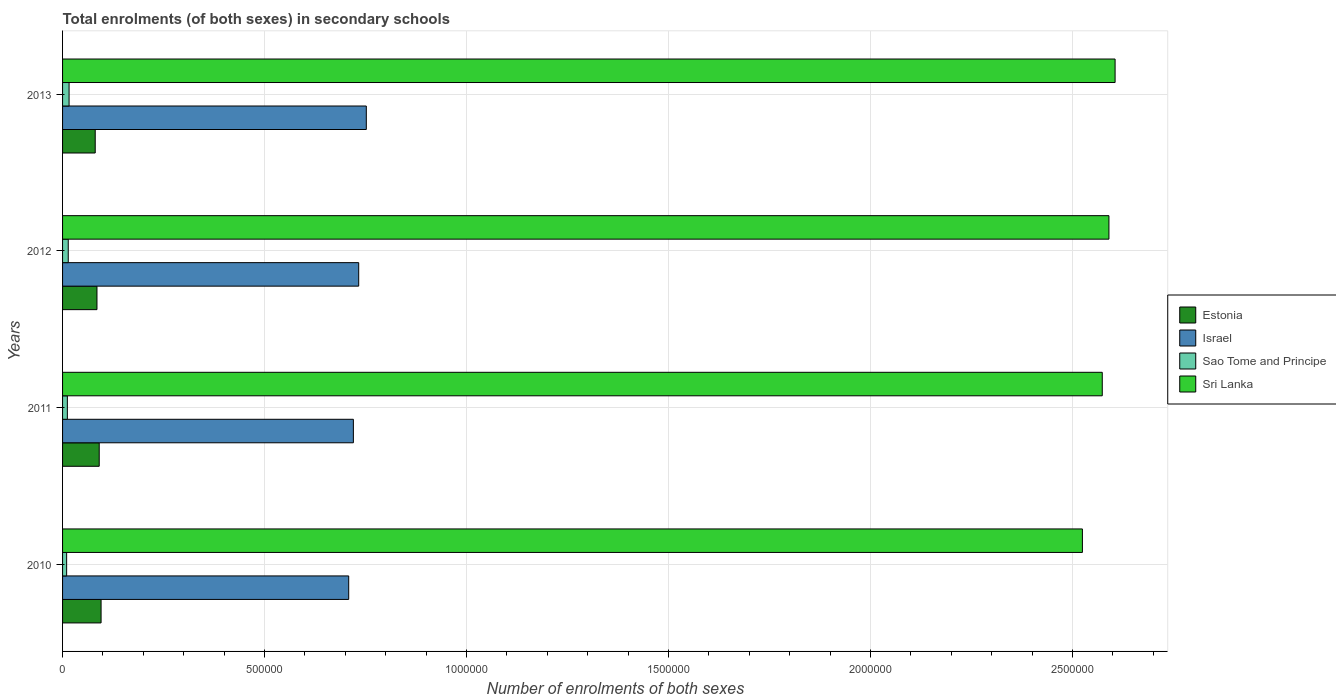Are the number of bars per tick equal to the number of legend labels?
Your answer should be compact. Yes. Are the number of bars on each tick of the Y-axis equal?
Offer a terse response. Yes. How many bars are there on the 1st tick from the bottom?
Provide a short and direct response. 4. In how many cases, is the number of bars for a given year not equal to the number of legend labels?
Your answer should be compact. 0. What is the number of enrolments in secondary schools in Sri Lanka in 2011?
Give a very brief answer. 2.57e+06. Across all years, what is the maximum number of enrolments in secondary schools in Sri Lanka?
Provide a short and direct response. 2.61e+06. Across all years, what is the minimum number of enrolments in secondary schools in Sao Tome and Principe?
Your response must be concise. 1.01e+04. In which year was the number of enrolments in secondary schools in Israel minimum?
Ensure brevity in your answer.  2010. What is the total number of enrolments in secondary schools in Sri Lanka in the graph?
Your answer should be very brief. 1.03e+07. What is the difference between the number of enrolments in secondary schools in Israel in 2011 and that in 2013?
Provide a short and direct response. -3.20e+04. What is the difference between the number of enrolments in secondary schools in Sao Tome and Principe in 2013 and the number of enrolments in secondary schools in Israel in 2012?
Provide a succinct answer. -7.17e+05. What is the average number of enrolments in secondary schools in Sri Lanka per year?
Your answer should be very brief. 2.57e+06. In the year 2011, what is the difference between the number of enrolments in secondary schools in Sao Tome and Principe and number of enrolments in secondary schools in Israel?
Ensure brevity in your answer.  -7.08e+05. In how many years, is the number of enrolments in secondary schools in Sri Lanka greater than 400000 ?
Your answer should be very brief. 4. What is the ratio of the number of enrolments in secondary schools in Sri Lanka in 2011 to that in 2012?
Provide a short and direct response. 0.99. Is the difference between the number of enrolments in secondary schools in Sao Tome and Principe in 2010 and 2012 greater than the difference between the number of enrolments in secondary schools in Israel in 2010 and 2012?
Give a very brief answer. Yes. What is the difference between the highest and the second highest number of enrolments in secondary schools in Sri Lanka?
Offer a very short reply. 1.52e+04. What is the difference between the highest and the lowest number of enrolments in secondary schools in Estonia?
Ensure brevity in your answer.  1.45e+04. In how many years, is the number of enrolments in secondary schools in Sao Tome and Principe greater than the average number of enrolments in secondary schools in Sao Tome and Principe taken over all years?
Your answer should be compact. 2. Is it the case that in every year, the sum of the number of enrolments in secondary schools in Estonia and number of enrolments in secondary schools in Israel is greater than the sum of number of enrolments in secondary schools in Sao Tome and Principe and number of enrolments in secondary schools in Sri Lanka?
Your answer should be compact. No. What does the 4th bar from the top in 2012 represents?
Your answer should be very brief. Estonia. What does the 1st bar from the bottom in 2013 represents?
Keep it short and to the point. Estonia. Is it the case that in every year, the sum of the number of enrolments in secondary schools in Israel and number of enrolments in secondary schools in Estonia is greater than the number of enrolments in secondary schools in Sao Tome and Principe?
Offer a very short reply. Yes. How many bars are there?
Provide a succinct answer. 16. Are all the bars in the graph horizontal?
Your answer should be compact. Yes. How many years are there in the graph?
Offer a terse response. 4. What is the difference between two consecutive major ticks on the X-axis?
Keep it short and to the point. 5.00e+05. How are the legend labels stacked?
Offer a terse response. Vertical. What is the title of the graph?
Provide a short and direct response. Total enrolments (of both sexes) in secondary schools. Does "South Africa" appear as one of the legend labels in the graph?
Ensure brevity in your answer.  No. What is the label or title of the X-axis?
Keep it short and to the point. Number of enrolments of both sexes. What is the Number of enrolments of both sexes in Estonia in 2010?
Keep it short and to the point. 9.53e+04. What is the Number of enrolments of both sexes of Israel in 2010?
Keep it short and to the point. 7.08e+05. What is the Number of enrolments of both sexes in Sao Tome and Principe in 2010?
Your answer should be very brief. 1.01e+04. What is the Number of enrolments of both sexes in Sri Lanka in 2010?
Make the answer very short. 2.52e+06. What is the Number of enrolments of both sexes of Estonia in 2011?
Offer a very short reply. 9.07e+04. What is the Number of enrolments of both sexes of Israel in 2011?
Offer a very short reply. 7.20e+05. What is the Number of enrolments of both sexes in Sao Tome and Principe in 2011?
Provide a succinct answer. 1.19e+04. What is the Number of enrolments of both sexes of Sri Lanka in 2011?
Provide a succinct answer. 2.57e+06. What is the Number of enrolments of both sexes of Estonia in 2012?
Your answer should be very brief. 8.52e+04. What is the Number of enrolments of both sexes in Israel in 2012?
Offer a terse response. 7.33e+05. What is the Number of enrolments of both sexes of Sao Tome and Principe in 2012?
Give a very brief answer. 1.41e+04. What is the Number of enrolments of both sexes in Sri Lanka in 2012?
Offer a very short reply. 2.59e+06. What is the Number of enrolments of both sexes in Estonia in 2013?
Your answer should be very brief. 8.08e+04. What is the Number of enrolments of both sexes in Israel in 2013?
Your response must be concise. 7.52e+05. What is the Number of enrolments of both sexes in Sao Tome and Principe in 2013?
Your answer should be very brief. 1.61e+04. What is the Number of enrolments of both sexes in Sri Lanka in 2013?
Your answer should be very brief. 2.61e+06. Across all years, what is the maximum Number of enrolments of both sexes in Estonia?
Offer a terse response. 9.53e+04. Across all years, what is the maximum Number of enrolments of both sexes of Israel?
Your answer should be very brief. 7.52e+05. Across all years, what is the maximum Number of enrolments of both sexes in Sao Tome and Principe?
Offer a terse response. 1.61e+04. Across all years, what is the maximum Number of enrolments of both sexes of Sri Lanka?
Make the answer very short. 2.61e+06. Across all years, what is the minimum Number of enrolments of both sexes of Estonia?
Offer a terse response. 8.08e+04. Across all years, what is the minimum Number of enrolments of both sexes in Israel?
Offer a terse response. 7.08e+05. Across all years, what is the minimum Number of enrolments of both sexes of Sao Tome and Principe?
Offer a terse response. 1.01e+04. Across all years, what is the minimum Number of enrolments of both sexes of Sri Lanka?
Your response must be concise. 2.52e+06. What is the total Number of enrolments of both sexes in Estonia in the graph?
Provide a short and direct response. 3.52e+05. What is the total Number of enrolments of both sexes of Israel in the graph?
Ensure brevity in your answer.  2.91e+06. What is the total Number of enrolments of both sexes of Sao Tome and Principe in the graph?
Provide a short and direct response. 5.22e+04. What is the total Number of enrolments of both sexes in Sri Lanka in the graph?
Ensure brevity in your answer.  1.03e+07. What is the difference between the Number of enrolments of both sexes of Estonia in 2010 and that in 2011?
Keep it short and to the point. 4614. What is the difference between the Number of enrolments of both sexes of Israel in 2010 and that in 2011?
Make the answer very short. -1.16e+04. What is the difference between the Number of enrolments of both sexes in Sao Tome and Principe in 2010 and that in 2011?
Offer a very short reply. -1787. What is the difference between the Number of enrolments of both sexes of Sri Lanka in 2010 and that in 2011?
Keep it short and to the point. -4.92e+04. What is the difference between the Number of enrolments of both sexes of Estonia in 2010 and that in 2012?
Offer a very short reply. 1.01e+04. What is the difference between the Number of enrolments of both sexes of Israel in 2010 and that in 2012?
Keep it short and to the point. -2.48e+04. What is the difference between the Number of enrolments of both sexes of Sao Tome and Principe in 2010 and that in 2012?
Keep it short and to the point. -3964. What is the difference between the Number of enrolments of both sexes in Sri Lanka in 2010 and that in 2012?
Your response must be concise. -6.57e+04. What is the difference between the Number of enrolments of both sexes of Estonia in 2010 and that in 2013?
Your answer should be very brief. 1.45e+04. What is the difference between the Number of enrolments of both sexes of Israel in 2010 and that in 2013?
Give a very brief answer. -4.36e+04. What is the difference between the Number of enrolments of both sexes of Sao Tome and Principe in 2010 and that in 2013?
Offer a very short reply. -6021. What is the difference between the Number of enrolments of both sexes of Sri Lanka in 2010 and that in 2013?
Keep it short and to the point. -8.09e+04. What is the difference between the Number of enrolments of both sexes of Estonia in 2011 and that in 2012?
Provide a succinct answer. 5534. What is the difference between the Number of enrolments of both sexes of Israel in 2011 and that in 2012?
Make the answer very short. -1.32e+04. What is the difference between the Number of enrolments of both sexes in Sao Tome and Principe in 2011 and that in 2012?
Keep it short and to the point. -2177. What is the difference between the Number of enrolments of both sexes in Sri Lanka in 2011 and that in 2012?
Provide a succinct answer. -1.65e+04. What is the difference between the Number of enrolments of both sexes in Estonia in 2011 and that in 2013?
Keep it short and to the point. 9877. What is the difference between the Number of enrolments of both sexes in Israel in 2011 and that in 2013?
Make the answer very short. -3.20e+04. What is the difference between the Number of enrolments of both sexes of Sao Tome and Principe in 2011 and that in 2013?
Your answer should be very brief. -4234. What is the difference between the Number of enrolments of both sexes of Sri Lanka in 2011 and that in 2013?
Keep it short and to the point. -3.18e+04. What is the difference between the Number of enrolments of both sexes of Estonia in 2012 and that in 2013?
Your answer should be very brief. 4343. What is the difference between the Number of enrolments of both sexes in Israel in 2012 and that in 2013?
Your answer should be very brief. -1.88e+04. What is the difference between the Number of enrolments of both sexes of Sao Tome and Principe in 2012 and that in 2013?
Ensure brevity in your answer.  -2057. What is the difference between the Number of enrolments of both sexes in Sri Lanka in 2012 and that in 2013?
Your response must be concise. -1.52e+04. What is the difference between the Number of enrolments of both sexes of Estonia in 2010 and the Number of enrolments of both sexes of Israel in 2011?
Provide a succinct answer. -6.25e+05. What is the difference between the Number of enrolments of both sexes in Estonia in 2010 and the Number of enrolments of both sexes in Sao Tome and Principe in 2011?
Give a very brief answer. 8.34e+04. What is the difference between the Number of enrolments of both sexes in Estonia in 2010 and the Number of enrolments of both sexes in Sri Lanka in 2011?
Keep it short and to the point. -2.48e+06. What is the difference between the Number of enrolments of both sexes of Israel in 2010 and the Number of enrolments of both sexes of Sao Tome and Principe in 2011?
Make the answer very short. 6.96e+05. What is the difference between the Number of enrolments of both sexes of Israel in 2010 and the Number of enrolments of both sexes of Sri Lanka in 2011?
Make the answer very short. -1.87e+06. What is the difference between the Number of enrolments of both sexes in Sao Tome and Principe in 2010 and the Number of enrolments of both sexes in Sri Lanka in 2011?
Give a very brief answer. -2.56e+06. What is the difference between the Number of enrolments of both sexes in Estonia in 2010 and the Number of enrolments of both sexes in Israel in 2012?
Ensure brevity in your answer.  -6.38e+05. What is the difference between the Number of enrolments of both sexes of Estonia in 2010 and the Number of enrolments of both sexes of Sao Tome and Principe in 2012?
Ensure brevity in your answer.  8.13e+04. What is the difference between the Number of enrolments of both sexes of Estonia in 2010 and the Number of enrolments of both sexes of Sri Lanka in 2012?
Ensure brevity in your answer.  -2.50e+06. What is the difference between the Number of enrolments of both sexes in Israel in 2010 and the Number of enrolments of both sexes in Sao Tome and Principe in 2012?
Your answer should be very brief. 6.94e+05. What is the difference between the Number of enrolments of both sexes in Israel in 2010 and the Number of enrolments of both sexes in Sri Lanka in 2012?
Keep it short and to the point. -1.88e+06. What is the difference between the Number of enrolments of both sexes of Sao Tome and Principe in 2010 and the Number of enrolments of both sexes of Sri Lanka in 2012?
Offer a terse response. -2.58e+06. What is the difference between the Number of enrolments of both sexes of Estonia in 2010 and the Number of enrolments of both sexes of Israel in 2013?
Make the answer very short. -6.57e+05. What is the difference between the Number of enrolments of both sexes in Estonia in 2010 and the Number of enrolments of both sexes in Sao Tome and Principe in 2013?
Provide a succinct answer. 7.92e+04. What is the difference between the Number of enrolments of both sexes in Estonia in 2010 and the Number of enrolments of both sexes in Sri Lanka in 2013?
Keep it short and to the point. -2.51e+06. What is the difference between the Number of enrolments of both sexes in Israel in 2010 and the Number of enrolments of both sexes in Sao Tome and Principe in 2013?
Provide a short and direct response. 6.92e+05. What is the difference between the Number of enrolments of both sexes in Israel in 2010 and the Number of enrolments of both sexes in Sri Lanka in 2013?
Keep it short and to the point. -1.90e+06. What is the difference between the Number of enrolments of both sexes in Sao Tome and Principe in 2010 and the Number of enrolments of both sexes in Sri Lanka in 2013?
Provide a succinct answer. -2.60e+06. What is the difference between the Number of enrolments of both sexes of Estonia in 2011 and the Number of enrolments of both sexes of Israel in 2012?
Provide a succinct answer. -6.42e+05. What is the difference between the Number of enrolments of both sexes of Estonia in 2011 and the Number of enrolments of both sexes of Sao Tome and Principe in 2012?
Your answer should be compact. 7.67e+04. What is the difference between the Number of enrolments of both sexes of Estonia in 2011 and the Number of enrolments of both sexes of Sri Lanka in 2012?
Offer a terse response. -2.50e+06. What is the difference between the Number of enrolments of both sexes in Israel in 2011 and the Number of enrolments of both sexes in Sao Tome and Principe in 2012?
Your answer should be very brief. 7.06e+05. What is the difference between the Number of enrolments of both sexes in Israel in 2011 and the Number of enrolments of both sexes in Sri Lanka in 2012?
Provide a succinct answer. -1.87e+06. What is the difference between the Number of enrolments of both sexes of Sao Tome and Principe in 2011 and the Number of enrolments of both sexes of Sri Lanka in 2012?
Your answer should be very brief. -2.58e+06. What is the difference between the Number of enrolments of both sexes of Estonia in 2011 and the Number of enrolments of both sexes of Israel in 2013?
Your answer should be very brief. -6.61e+05. What is the difference between the Number of enrolments of both sexes of Estonia in 2011 and the Number of enrolments of both sexes of Sao Tome and Principe in 2013?
Provide a succinct answer. 7.46e+04. What is the difference between the Number of enrolments of both sexes in Estonia in 2011 and the Number of enrolments of both sexes in Sri Lanka in 2013?
Provide a short and direct response. -2.51e+06. What is the difference between the Number of enrolments of both sexes in Israel in 2011 and the Number of enrolments of both sexes in Sao Tome and Principe in 2013?
Offer a terse response. 7.04e+05. What is the difference between the Number of enrolments of both sexes of Israel in 2011 and the Number of enrolments of both sexes of Sri Lanka in 2013?
Your answer should be very brief. -1.89e+06. What is the difference between the Number of enrolments of both sexes in Sao Tome and Principe in 2011 and the Number of enrolments of both sexes in Sri Lanka in 2013?
Give a very brief answer. -2.59e+06. What is the difference between the Number of enrolments of both sexes of Estonia in 2012 and the Number of enrolments of both sexes of Israel in 2013?
Offer a terse response. -6.67e+05. What is the difference between the Number of enrolments of both sexes of Estonia in 2012 and the Number of enrolments of both sexes of Sao Tome and Principe in 2013?
Ensure brevity in your answer.  6.91e+04. What is the difference between the Number of enrolments of both sexes in Estonia in 2012 and the Number of enrolments of both sexes in Sri Lanka in 2013?
Give a very brief answer. -2.52e+06. What is the difference between the Number of enrolments of both sexes of Israel in 2012 and the Number of enrolments of both sexes of Sao Tome and Principe in 2013?
Your response must be concise. 7.17e+05. What is the difference between the Number of enrolments of both sexes of Israel in 2012 and the Number of enrolments of both sexes of Sri Lanka in 2013?
Provide a short and direct response. -1.87e+06. What is the difference between the Number of enrolments of both sexes in Sao Tome and Principe in 2012 and the Number of enrolments of both sexes in Sri Lanka in 2013?
Keep it short and to the point. -2.59e+06. What is the average Number of enrolments of both sexes in Estonia per year?
Make the answer very short. 8.80e+04. What is the average Number of enrolments of both sexes in Israel per year?
Provide a short and direct response. 7.28e+05. What is the average Number of enrolments of both sexes in Sao Tome and Principe per year?
Provide a short and direct response. 1.30e+04. What is the average Number of enrolments of both sexes in Sri Lanka per year?
Keep it short and to the point. 2.57e+06. In the year 2010, what is the difference between the Number of enrolments of both sexes of Estonia and Number of enrolments of both sexes of Israel?
Ensure brevity in your answer.  -6.13e+05. In the year 2010, what is the difference between the Number of enrolments of both sexes of Estonia and Number of enrolments of both sexes of Sao Tome and Principe?
Give a very brief answer. 8.52e+04. In the year 2010, what is the difference between the Number of enrolments of both sexes in Estonia and Number of enrolments of both sexes in Sri Lanka?
Give a very brief answer. -2.43e+06. In the year 2010, what is the difference between the Number of enrolments of both sexes of Israel and Number of enrolments of both sexes of Sao Tome and Principe?
Make the answer very short. 6.98e+05. In the year 2010, what is the difference between the Number of enrolments of both sexes of Israel and Number of enrolments of both sexes of Sri Lanka?
Ensure brevity in your answer.  -1.82e+06. In the year 2010, what is the difference between the Number of enrolments of both sexes in Sao Tome and Principe and Number of enrolments of both sexes in Sri Lanka?
Offer a terse response. -2.51e+06. In the year 2011, what is the difference between the Number of enrolments of both sexes of Estonia and Number of enrolments of both sexes of Israel?
Your response must be concise. -6.29e+05. In the year 2011, what is the difference between the Number of enrolments of both sexes of Estonia and Number of enrolments of both sexes of Sao Tome and Principe?
Keep it short and to the point. 7.88e+04. In the year 2011, what is the difference between the Number of enrolments of both sexes in Estonia and Number of enrolments of both sexes in Sri Lanka?
Ensure brevity in your answer.  -2.48e+06. In the year 2011, what is the difference between the Number of enrolments of both sexes of Israel and Number of enrolments of both sexes of Sao Tome and Principe?
Provide a succinct answer. 7.08e+05. In the year 2011, what is the difference between the Number of enrolments of both sexes in Israel and Number of enrolments of both sexes in Sri Lanka?
Offer a very short reply. -1.85e+06. In the year 2011, what is the difference between the Number of enrolments of both sexes of Sao Tome and Principe and Number of enrolments of both sexes of Sri Lanka?
Make the answer very short. -2.56e+06. In the year 2012, what is the difference between the Number of enrolments of both sexes in Estonia and Number of enrolments of both sexes in Israel?
Your response must be concise. -6.48e+05. In the year 2012, what is the difference between the Number of enrolments of both sexes of Estonia and Number of enrolments of both sexes of Sao Tome and Principe?
Your answer should be compact. 7.11e+04. In the year 2012, what is the difference between the Number of enrolments of both sexes of Estonia and Number of enrolments of both sexes of Sri Lanka?
Provide a short and direct response. -2.51e+06. In the year 2012, what is the difference between the Number of enrolments of both sexes of Israel and Number of enrolments of both sexes of Sao Tome and Principe?
Your answer should be very brief. 7.19e+05. In the year 2012, what is the difference between the Number of enrolments of both sexes of Israel and Number of enrolments of both sexes of Sri Lanka?
Offer a terse response. -1.86e+06. In the year 2012, what is the difference between the Number of enrolments of both sexes of Sao Tome and Principe and Number of enrolments of both sexes of Sri Lanka?
Offer a terse response. -2.58e+06. In the year 2013, what is the difference between the Number of enrolments of both sexes in Estonia and Number of enrolments of both sexes in Israel?
Provide a succinct answer. -6.71e+05. In the year 2013, what is the difference between the Number of enrolments of both sexes in Estonia and Number of enrolments of both sexes in Sao Tome and Principe?
Your answer should be very brief. 6.47e+04. In the year 2013, what is the difference between the Number of enrolments of both sexes in Estonia and Number of enrolments of both sexes in Sri Lanka?
Provide a succinct answer. -2.52e+06. In the year 2013, what is the difference between the Number of enrolments of both sexes in Israel and Number of enrolments of both sexes in Sao Tome and Principe?
Provide a succinct answer. 7.36e+05. In the year 2013, what is the difference between the Number of enrolments of both sexes of Israel and Number of enrolments of both sexes of Sri Lanka?
Provide a succinct answer. -1.85e+06. In the year 2013, what is the difference between the Number of enrolments of both sexes of Sao Tome and Principe and Number of enrolments of both sexes of Sri Lanka?
Offer a terse response. -2.59e+06. What is the ratio of the Number of enrolments of both sexes of Estonia in 2010 to that in 2011?
Your response must be concise. 1.05. What is the ratio of the Number of enrolments of both sexes in Israel in 2010 to that in 2011?
Offer a terse response. 0.98. What is the ratio of the Number of enrolments of both sexes in Sao Tome and Principe in 2010 to that in 2011?
Provide a succinct answer. 0.85. What is the ratio of the Number of enrolments of both sexes in Sri Lanka in 2010 to that in 2011?
Offer a very short reply. 0.98. What is the ratio of the Number of enrolments of both sexes of Estonia in 2010 to that in 2012?
Make the answer very short. 1.12. What is the ratio of the Number of enrolments of both sexes of Israel in 2010 to that in 2012?
Make the answer very short. 0.97. What is the ratio of the Number of enrolments of both sexes in Sao Tome and Principe in 2010 to that in 2012?
Provide a succinct answer. 0.72. What is the ratio of the Number of enrolments of both sexes of Sri Lanka in 2010 to that in 2012?
Make the answer very short. 0.97. What is the ratio of the Number of enrolments of both sexes in Estonia in 2010 to that in 2013?
Provide a short and direct response. 1.18. What is the ratio of the Number of enrolments of both sexes of Israel in 2010 to that in 2013?
Make the answer very short. 0.94. What is the ratio of the Number of enrolments of both sexes in Sao Tome and Principe in 2010 to that in 2013?
Offer a terse response. 0.63. What is the ratio of the Number of enrolments of both sexes of Sri Lanka in 2010 to that in 2013?
Keep it short and to the point. 0.97. What is the ratio of the Number of enrolments of both sexes of Estonia in 2011 to that in 2012?
Provide a succinct answer. 1.06. What is the ratio of the Number of enrolments of both sexes of Israel in 2011 to that in 2012?
Your answer should be very brief. 0.98. What is the ratio of the Number of enrolments of both sexes in Sao Tome and Principe in 2011 to that in 2012?
Your response must be concise. 0.85. What is the ratio of the Number of enrolments of both sexes in Estonia in 2011 to that in 2013?
Offer a terse response. 1.12. What is the ratio of the Number of enrolments of both sexes of Israel in 2011 to that in 2013?
Offer a terse response. 0.96. What is the ratio of the Number of enrolments of both sexes in Sao Tome and Principe in 2011 to that in 2013?
Offer a very short reply. 0.74. What is the ratio of the Number of enrolments of both sexes of Sri Lanka in 2011 to that in 2013?
Provide a short and direct response. 0.99. What is the ratio of the Number of enrolments of both sexes in Estonia in 2012 to that in 2013?
Provide a short and direct response. 1.05. What is the ratio of the Number of enrolments of both sexes of Israel in 2012 to that in 2013?
Give a very brief answer. 0.97. What is the ratio of the Number of enrolments of both sexes in Sao Tome and Principe in 2012 to that in 2013?
Your response must be concise. 0.87. What is the ratio of the Number of enrolments of both sexes in Sri Lanka in 2012 to that in 2013?
Make the answer very short. 0.99. What is the difference between the highest and the second highest Number of enrolments of both sexes of Estonia?
Keep it short and to the point. 4614. What is the difference between the highest and the second highest Number of enrolments of both sexes of Israel?
Keep it short and to the point. 1.88e+04. What is the difference between the highest and the second highest Number of enrolments of both sexes in Sao Tome and Principe?
Give a very brief answer. 2057. What is the difference between the highest and the second highest Number of enrolments of both sexes in Sri Lanka?
Keep it short and to the point. 1.52e+04. What is the difference between the highest and the lowest Number of enrolments of both sexes of Estonia?
Make the answer very short. 1.45e+04. What is the difference between the highest and the lowest Number of enrolments of both sexes of Israel?
Your answer should be compact. 4.36e+04. What is the difference between the highest and the lowest Number of enrolments of both sexes of Sao Tome and Principe?
Offer a very short reply. 6021. What is the difference between the highest and the lowest Number of enrolments of both sexes in Sri Lanka?
Your answer should be compact. 8.09e+04. 